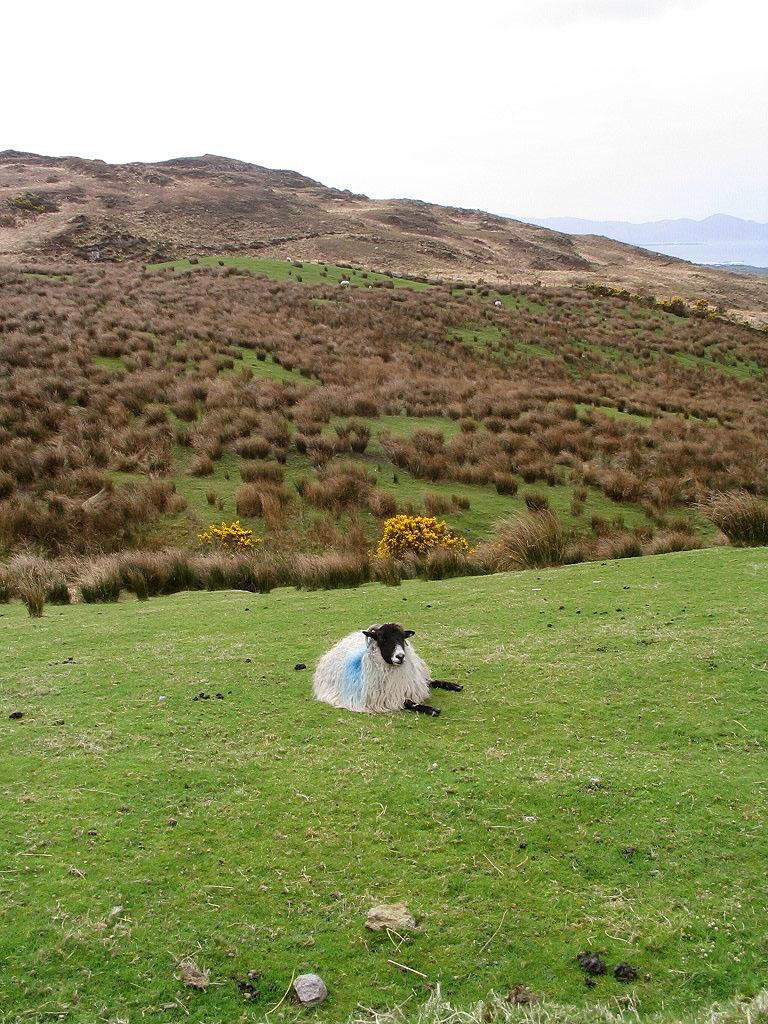What is the main subject in the center of the image? There is an animal in the center of the image. What type of terrain is visible at the bottom of the image? There is grass at the bottom of the image. What can be seen in the distance in the image? There are hills in the background of the image. What is visible above the hills in the image? The sky is visible in the background of the image. Is there a rail system visible in the image? There is no rail system present in the image. Can you see a volcano in the background of the image? There is no volcano visible in the image; only hills and the sky are present. 